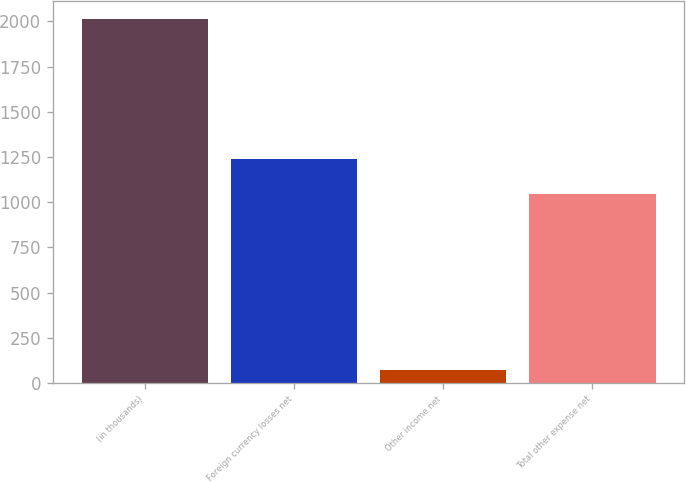<chart> <loc_0><loc_0><loc_500><loc_500><bar_chart><fcel>(in thousands)<fcel>Foreign currency losses net<fcel>Other income net<fcel>Total other expense net<nl><fcel>2013<fcel>1240.4<fcel>69<fcel>1046<nl></chart> 